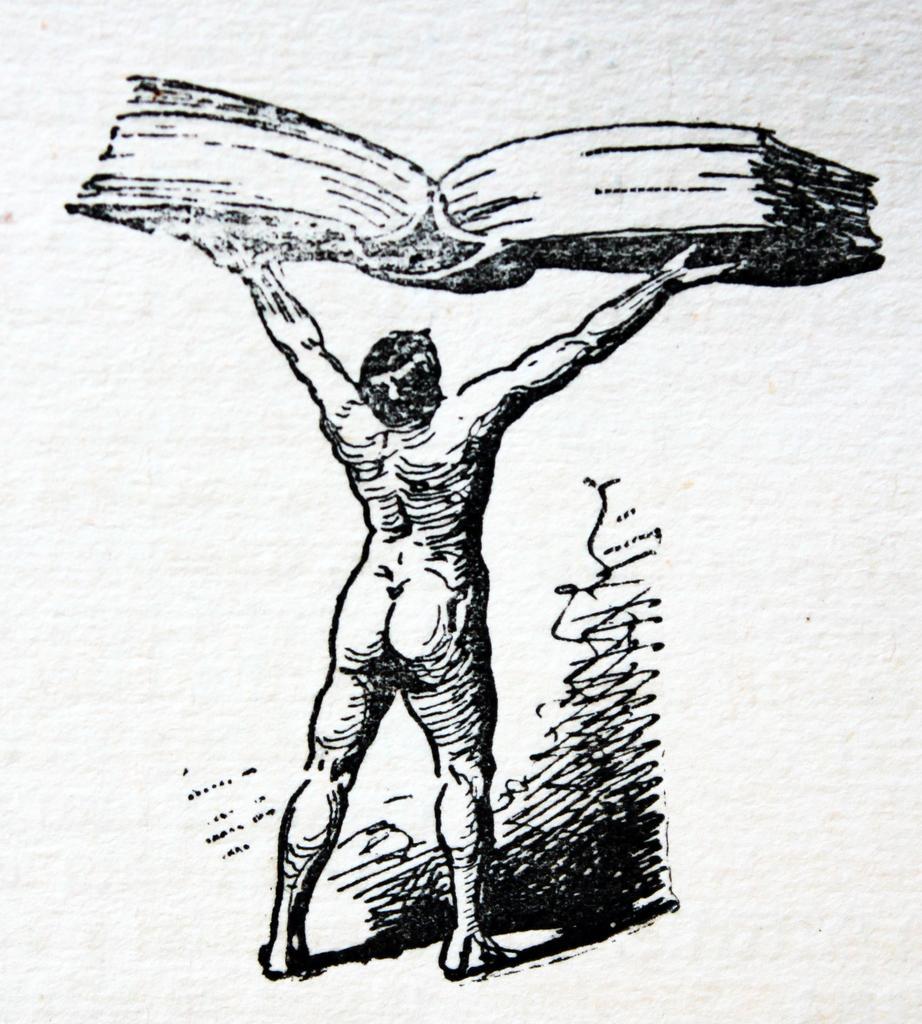Please provide a concise description of this image. In this image we can see a sketch on the paper. In the center there is a man standing and holding a book. 